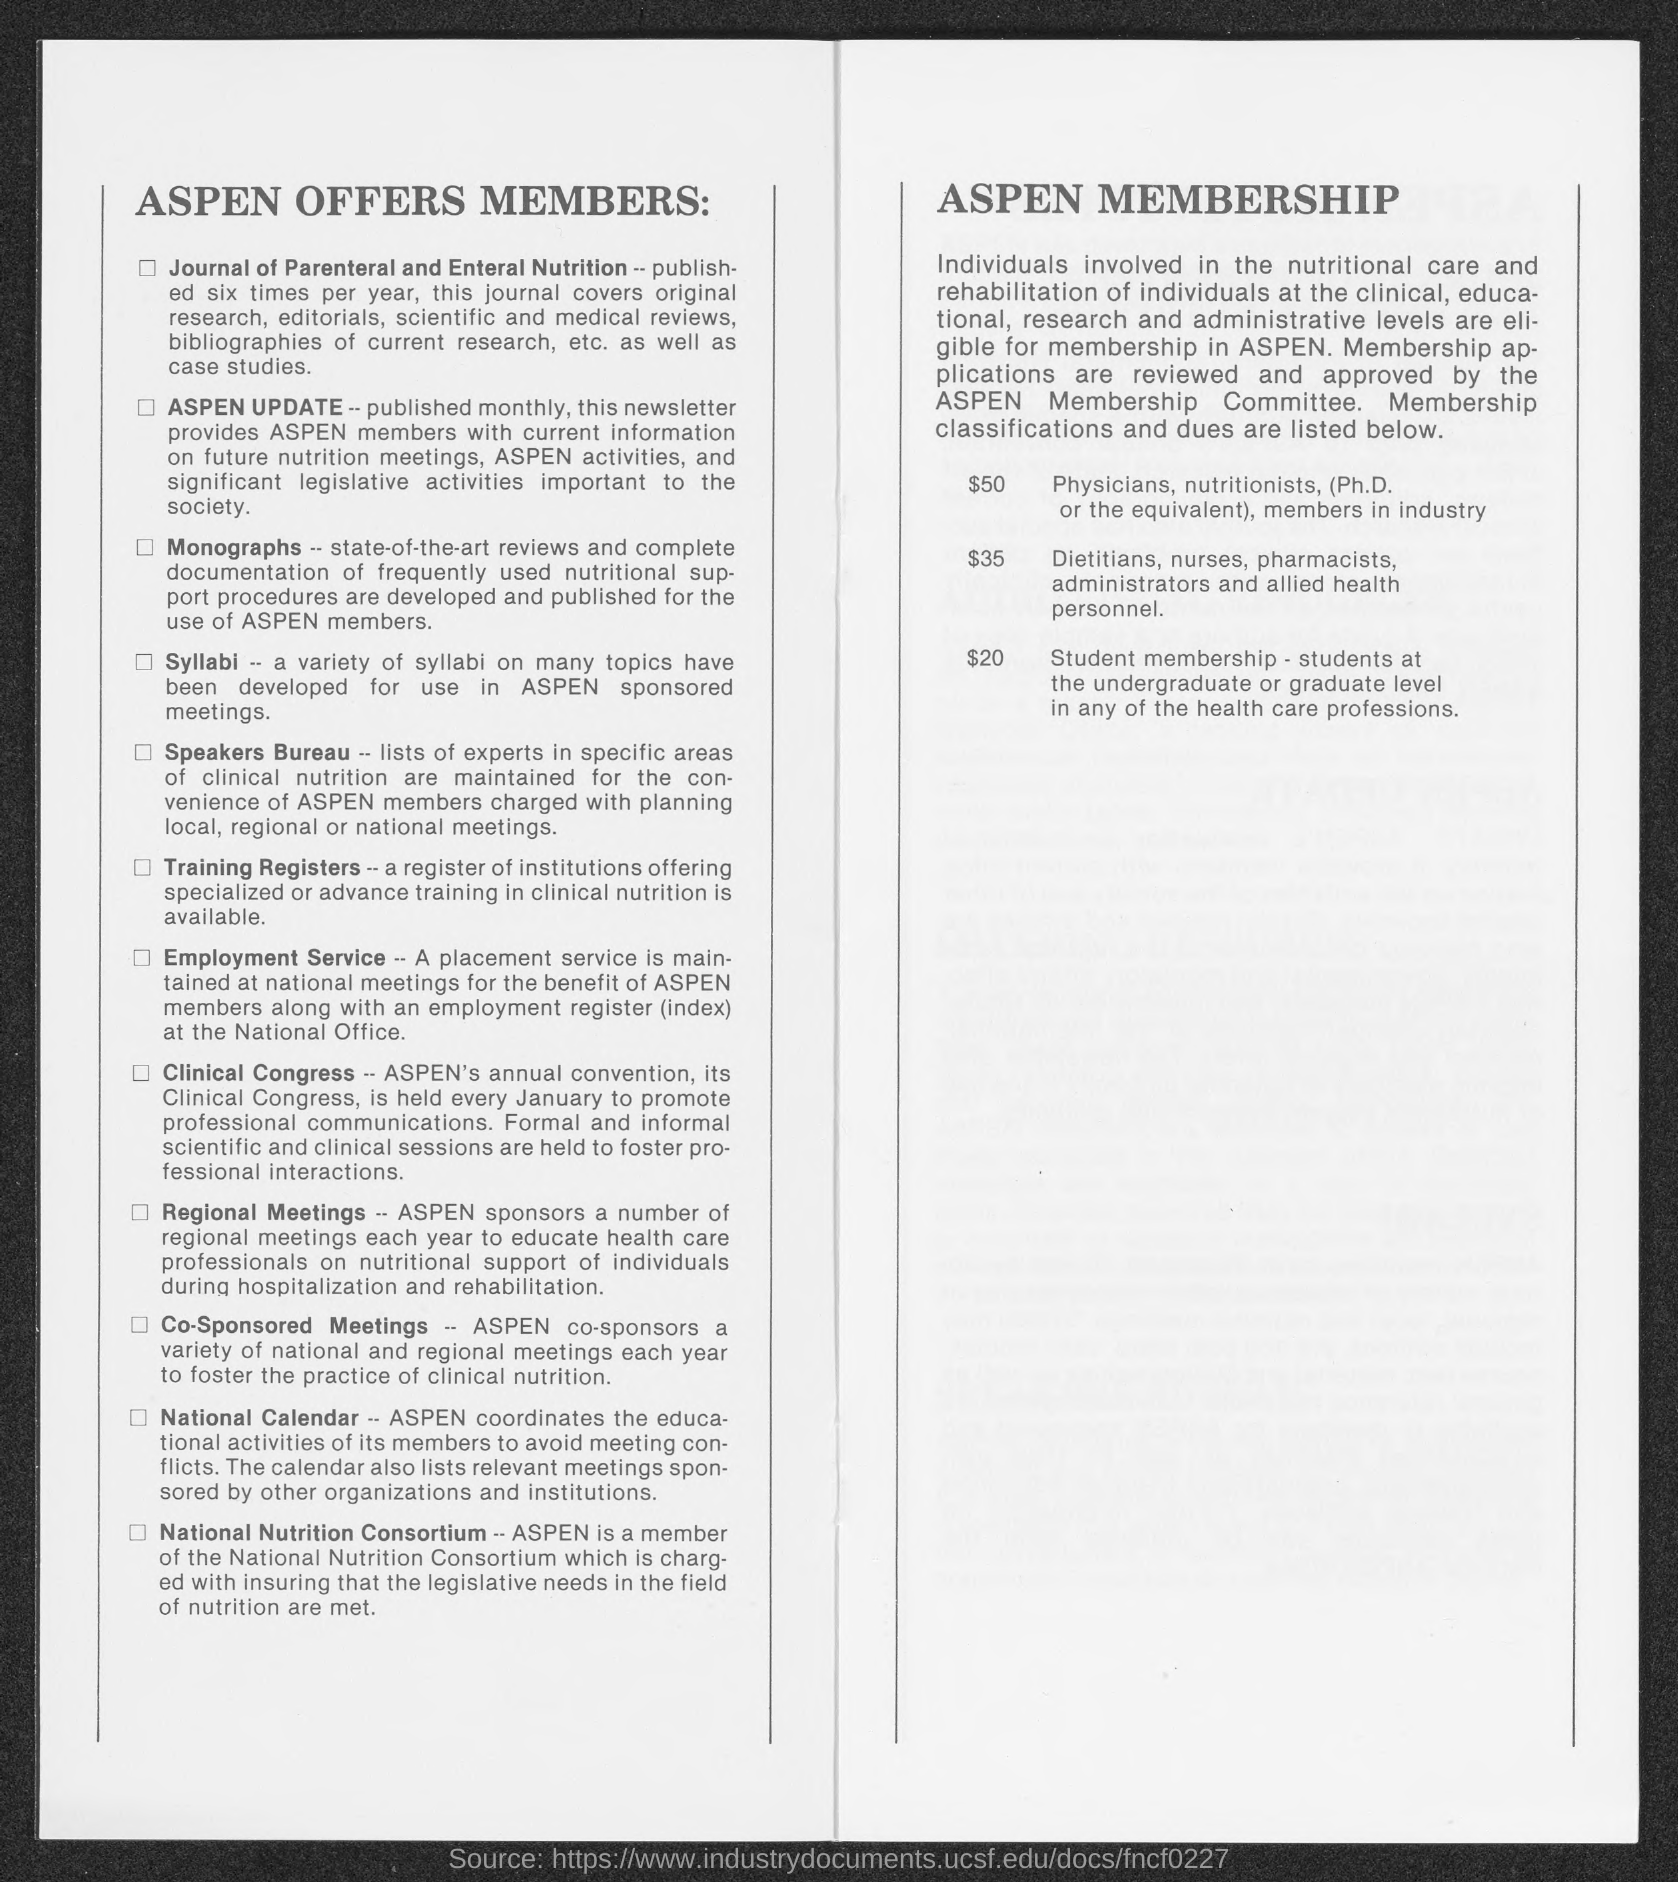List a handful of essential elements in this visual. The Journal of Parental and Enteral Nutrition is published six times per year. 